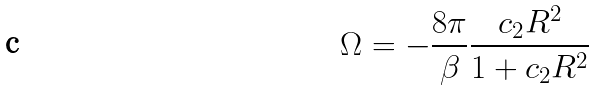Convert formula to latex. <formula><loc_0><loc_0><loc_500><loc_500>\Omega = - \frac { 8 \pi } { \beta } \frac { c _ { 2 } R ^ { 2 } } { 1 + c _ { 2 } R ^ { 2 } }</formula> 